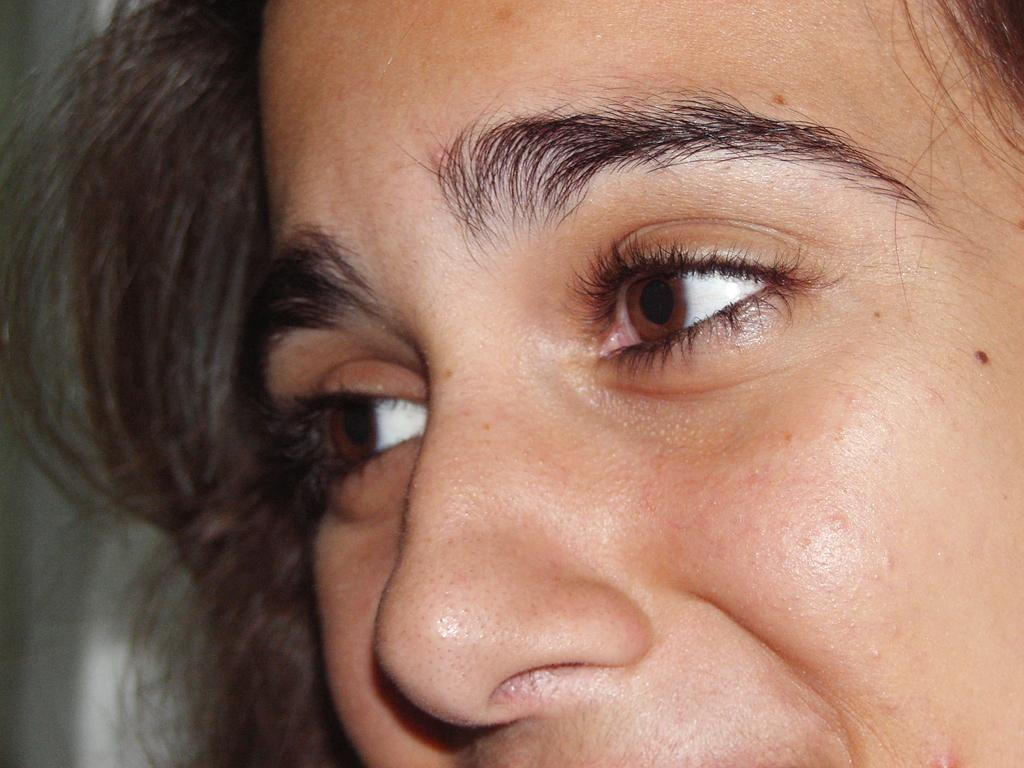What is the main subject of the image? The main subject of the image is a woman's face. Can you describe any features of the woman's appearance? The woman has hair. What can you tell me about the background of the image? The background of the image is not clear enough to describe. What type of teeth can be seen in the image? There are no teeth visible in the image, as it features a woman's face and not her mouth. 